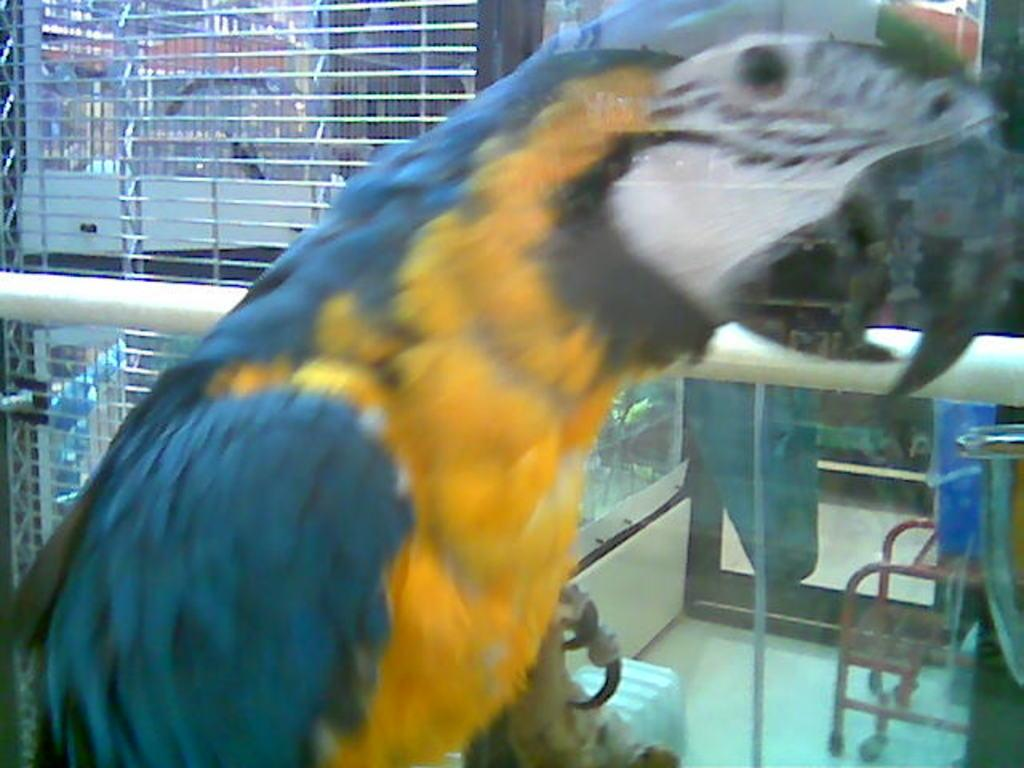What type of animal is in the image? There is a parrot in the image. What object is present in the image that might be related to the parrot? There is a rod in the image, which appears to be part of a cage. How many cages can be seen in the image? There are multiple cages in the image. What can be seen in the background of the image? There are objects visible in the background of the image. Can you describe the smoke coming from the airplane in the image? There is no airplane or smoke present in the image; it features a parrot and multiple cages. 